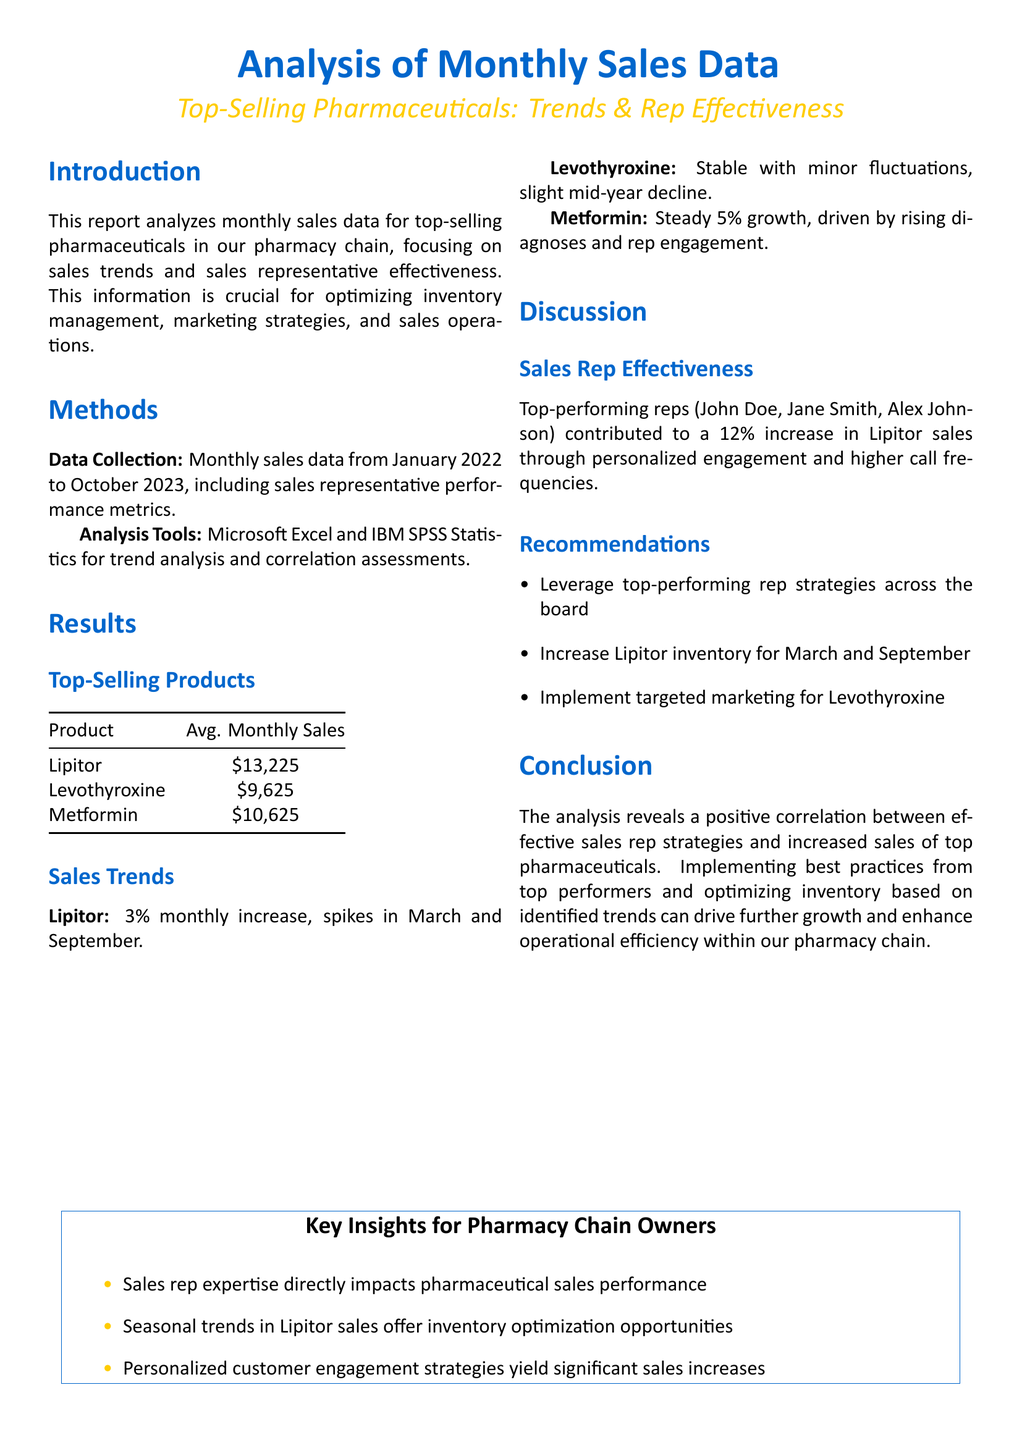What are the top-selling products? The top-selling products listed in the document are Lipitor, Levothyroxine, and Metformin.
Answer: Lipitor, Levothyroxine, Metformin What is the average monthly sales for Lipitor? The average monthly sales for Lipitor in the document is specified in the table.
Answer: $13,225 What percentage increase is noted for Lipitor sales? The document states that there is a 3% monthly increase in Lipitor sales.
Answer: 3% Who are the top-performing sales representatives mentioned? The document lists the top-performing representatives contributing to sales.
Answer: John Doe, Jane Smith, Alex Johnson What was the monthly sales growth percentage for Metformin? The sales growth percentage for Metformin is provided as a steady growth rate.
Answer: 5% What recommendation is made regarding Lipitor inventory? The recommendation section of the document includes specific inventory actions based on sales trends.
Answer: Increase inventory for March and September What specific analysis tools were used in this report? The methods section specifies the tools for analysis of the sales data.
Answer: Microsoft Excel, IBM SPSS Statistics Which product had a slight mid-year decline in sales? The sales trends section provides insight into the performance trends of each product.
Answer: Levothyroxine What correlation was found between sales rep strategies and pharmaceuticals? The conclusion mentions the findings about sales rep effectiveness on sales.
Answer: Positive correlation 